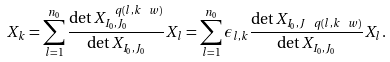<formula> <loc_0><loc_0><loc_500><loc_500>X _ { k } = \sum _ { l = 1 } ^ { n _ { 0 } } \frac { \det X ^ { \ q ( l , k \ w ) } _ { I _ { 0 } , J _ { 0 } } } { \det X _ { I _ { 0 } , J _ { 0 } } } X _ { l } = \sum _ { l = 1 } ^ { n _ { 0 } } \epsilon _ { l , k } \frac { \det X _ { I _ { 0 } , J \ q ( l , k \ w ) } } { \det X _ { I _ { 0 } , J _ { 0 } } } X _ { l } .</formula> 